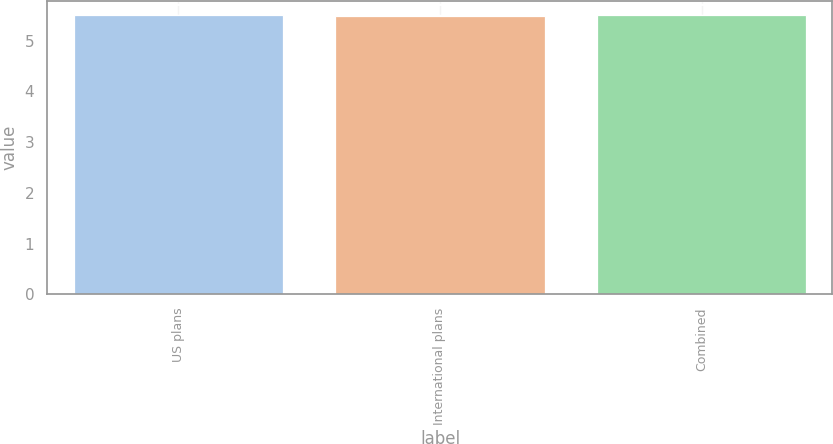Convert chart to OTSL. <chart><loc_0><loc_0><loc_500><loc_500><bar_chart><fcel>US plans<fcel>International plans<fcel>Combined<nl><fcel>5.5<fcel>5.49<fcel>5.5<nl></chart> 